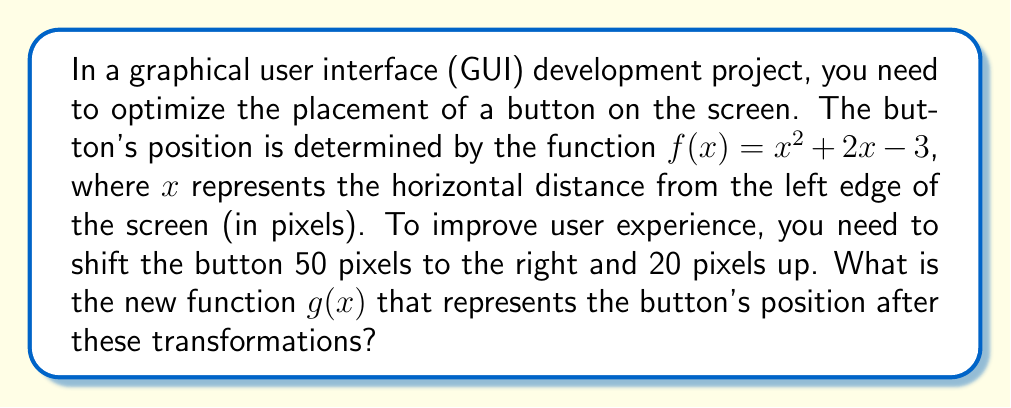Can you answer this question? To solve this problem, we need to apply both horizontal and vertical shifts to the original function $f(x)$. Let's break it down step-by-step:

1. Original function: $f(x) = x^2 + 2x - 3$

2. Horizontal shift:
   To shift the function 50 pixels to the right, we replace $x$ with $(x - 50)$:
   $f(x - 50) = (x - 50)^2 + 2(x - 50) - 3$

3. Expand the squared term:
   $f(x - 50) = x^2 - 100x + 2500 + 2x - 100 - 3$

4. Simplify:
   $f(x - 50) = x^2 - 98x + 2397$

5. Vertical shift:
   To shift the function 20 pixels up, we add 20 to the entire function:
   $g(x) = f(x - 50) + 20$

6. Apply the vertical shift:
   $g(x) = (x^2 - 98x + 2397) + 20$

7. Simplify the final function:
   $g(x) = x^2 - 98x + 2417$

This new function $g(x)$ represents the button's position after shifting it 50 pixels to the right and 20 pixels up.
Answer: $g(x) = x^2 - 98x + 2417$ 